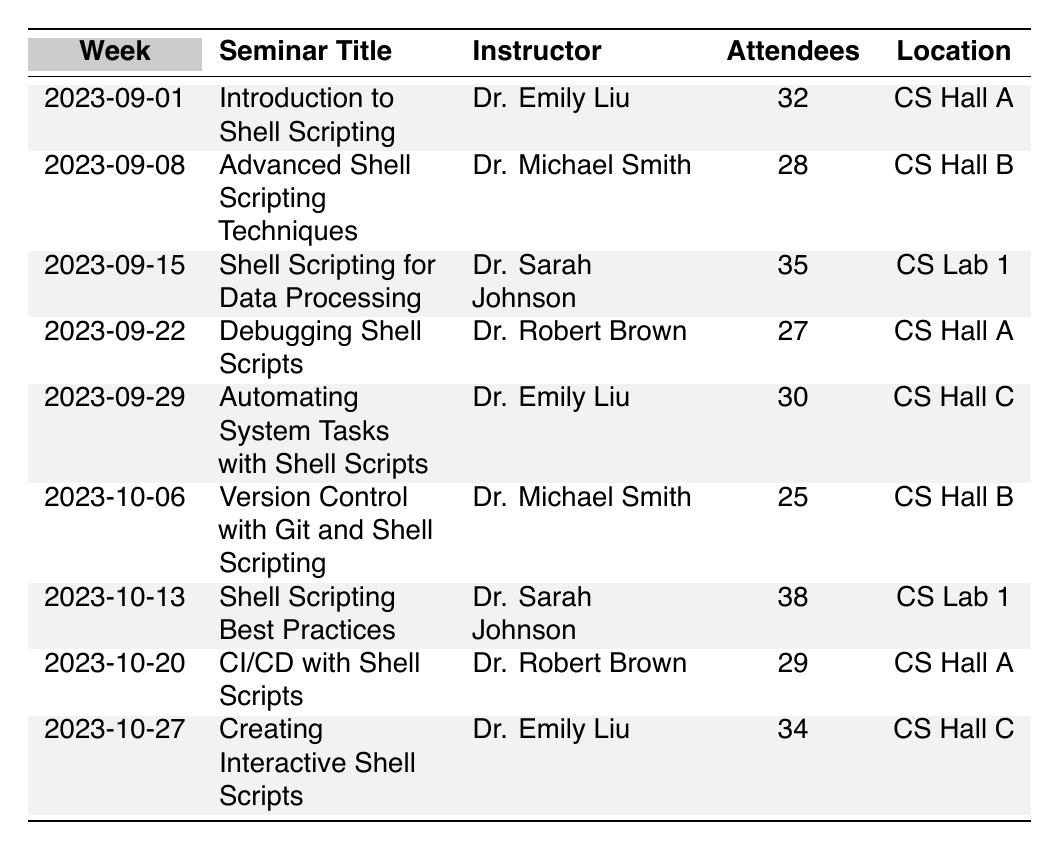What is the seminar title held on 2023-09-15? Referring to the table, on the week of 2023-09-15, the seminar title listed is "Shell Scripting for Data Processing."
Answer: "Shell Scripting for Data Processing" Who is the instructor for the seminar titled "Debugging Shell Scripts"? Looking at the row for the seminar "Debugging Shell Scripts," the instructor mentioned is Dr. Robert Brown.
Answer: Dr. Robert Brown How many attendees were present for "Shell Scripting Best Practices"? The table indicates that "Shell Scripting Best Practices" had 38 attendees as recorded on 2023-10-13.
Answer: 38 What is the total number of attendees across all seminars? To find the total number of attendees, sum the attendee counts: 32 + 28 + 35 + 27 + 30 + 25 + 38 + 29 + 34 = 308.
Answer: 308 Which seminar had the highest attendance and what was the count? By examining the attendance numbers, "Shell Scripting Best Practices" had the highest attendance with 38 attendees.
Answer: "Shell Scripting Best Practices", 38 Did any seminar on 2023-10-06 have more than 30 attendees? Checking the attendance for the seminar on this date, "Version Control with Git and Shell Scripting" had 25 attendees, which is less than 30.
Answer: No What percentage of the seminars had more than 30 attendees? Count the seminars with attendance greater than 30, which are: 32, 35, 38, and 34 (4 seminars). There are a total of 9 seminars. Thus, the percentage is (4/9)*100 = 44.44%.
Answer: 44.44% Which instructor taught the most seminars? Count the number of seminars per instructor: Dr. Emily Liu (3), Dr. Michael Smith (2), Dr. Sarah Johnson (2), and Dr. Robert Brown (2). Dr. Emily Liu taught the most (3 seminars).
Answer: Dr. Emily Liu What was the attendance difference between the seminar "Creating Interactive Shell Scripts" and "Version Control with Git and Shell Scripting"? "Creating Interactive Shell Scripts" had 34 attendees, while "Version Control with Git and Shell Scripting" had 25 attendees. The difference is 34 - 25 = 9.
Answer: 9 Was the attendance for seminars taught by Dr. Sarah Johnson consistently above 30? The attendances for Dr. Sarah Johnson are 35 and 38. Both are above 30, hence attendance was consistent.
Answer: Yes 